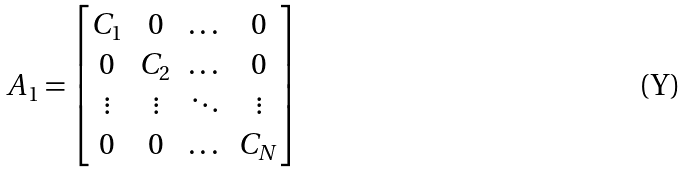<formula> <loc_0><loc_0><loc_500><loc_500>A _ { 1 } = \begin{bmatrix} C _ { 1 } & 0 & \dots & 0 \\ 0 & C _ { 2 } & \dots & 0 \\ \vdots & \vdots & \ddots & \vdots \\ 0 & 0 & \dots & C _ { N } \end{bmatrix}</formula> 